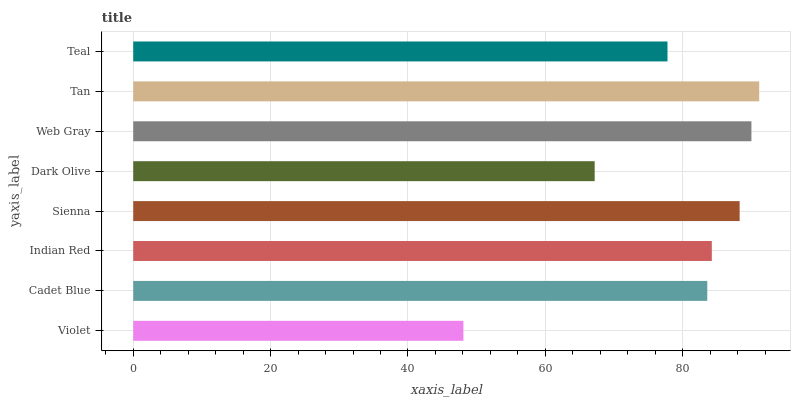Is Violet the minimum?
Answer yes or no. Yes. Is Tan the maximum?
Answer yes or no. Yes. Is Cadet Blue the minimum?
Answer yes or no. No. Is Cadet Blue the maximum?
Answer yes or no. No. Is Cadet Blue greater than Violet?
Answer yes or no. Yes. Is Violet less than Cadet Blue?
Answer yes or no. Yes. Is Violet greater than Cadet Blue?
Answer yes or no. No. Is Cadet Blue less than Violet?
Answer yes or no. No. Is Indian Red the high median?
Answer yes or no. Yes. Is Cadet Blue the low median?
Answer yes or no. Yes. Is Web Gray the high median?
Answer yes or no. No. Is Violet the low median?
Answer yes or no. No. 